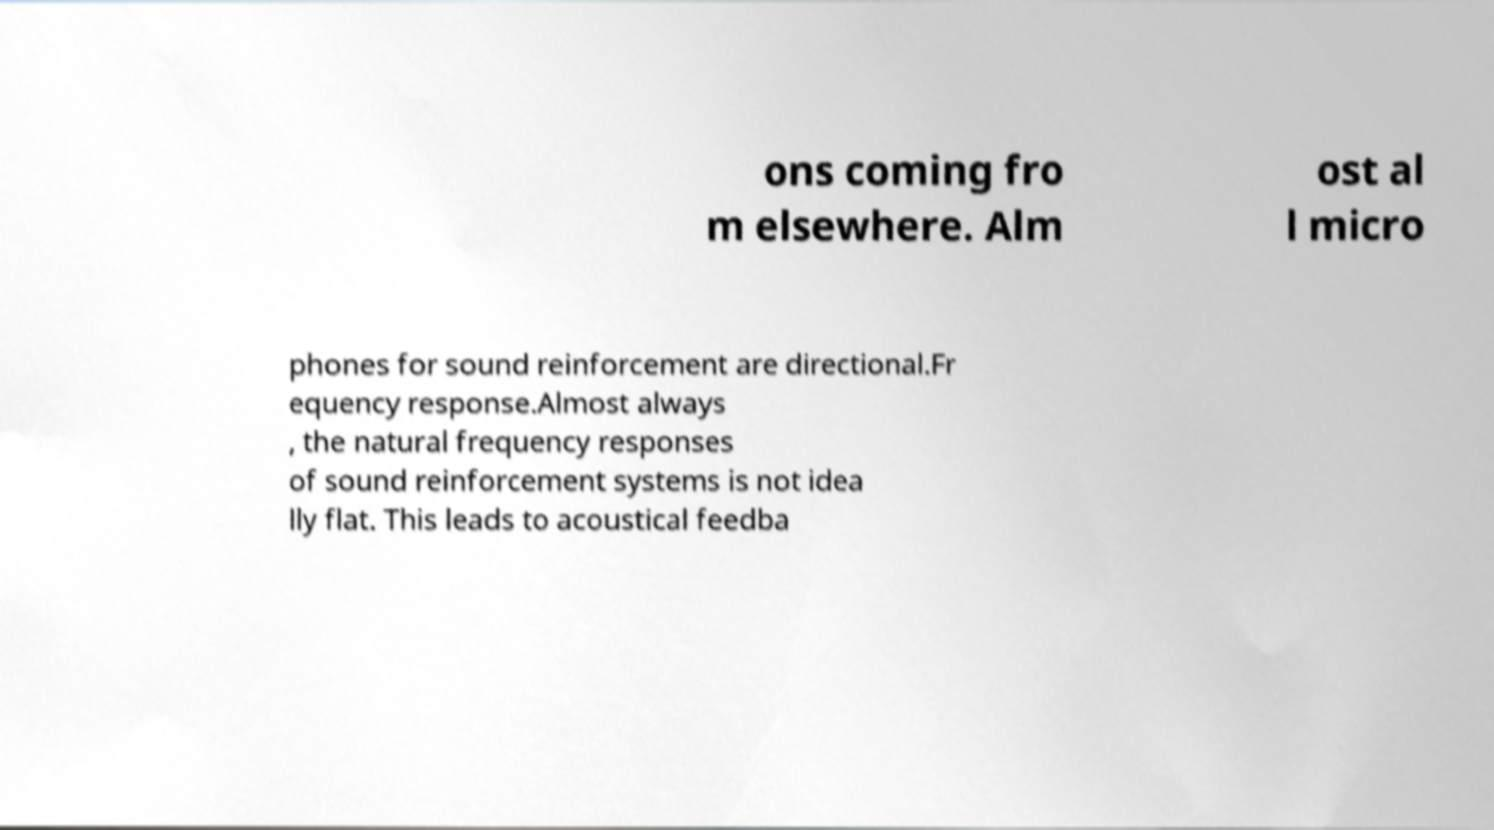Can you accurately transcribe the text from the provided image for me? ons coming fro m elsewhere. Alm ost al l micro phones for sound reinforcement are directional.Fr equency response.Almost always , the natural frequency responses of sound reinforcement systems is not idea lly flat. This leads to acoustical feedba 